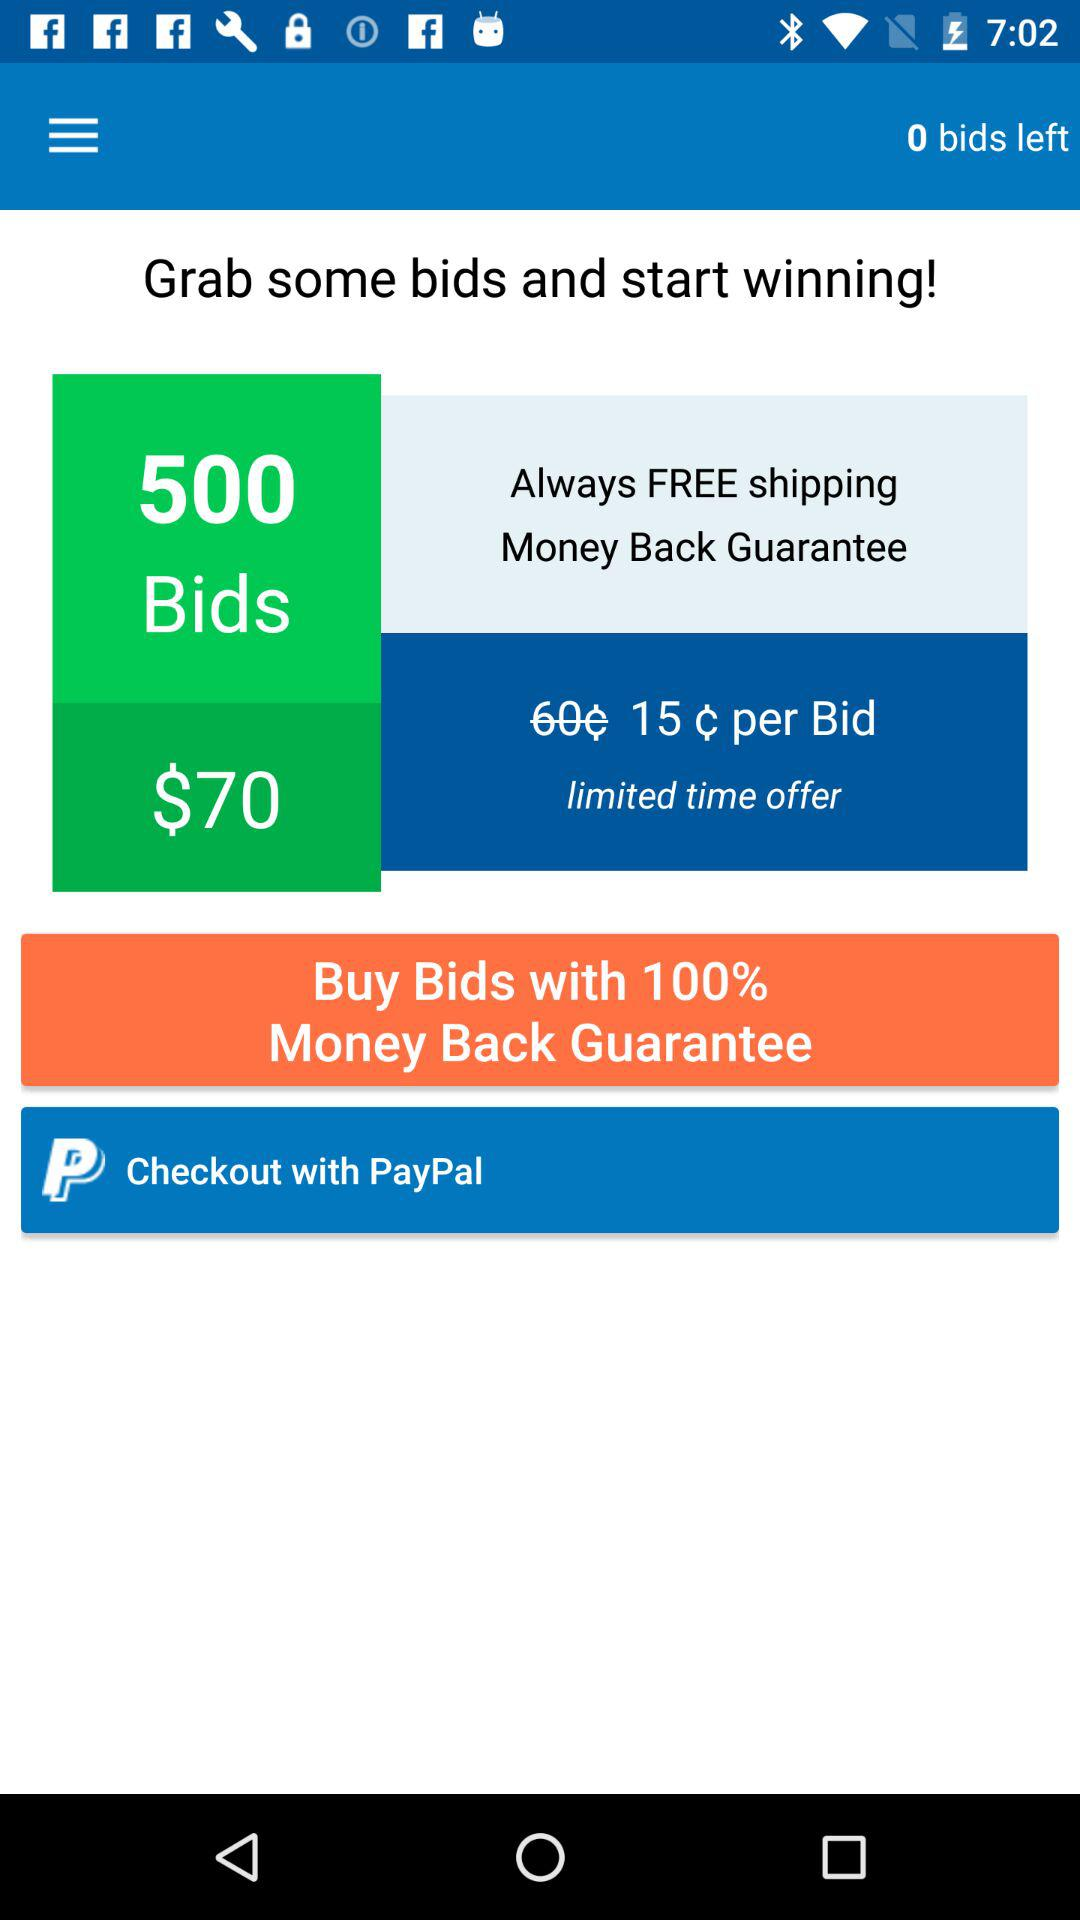How many bids are left? There are 0 bids left. 